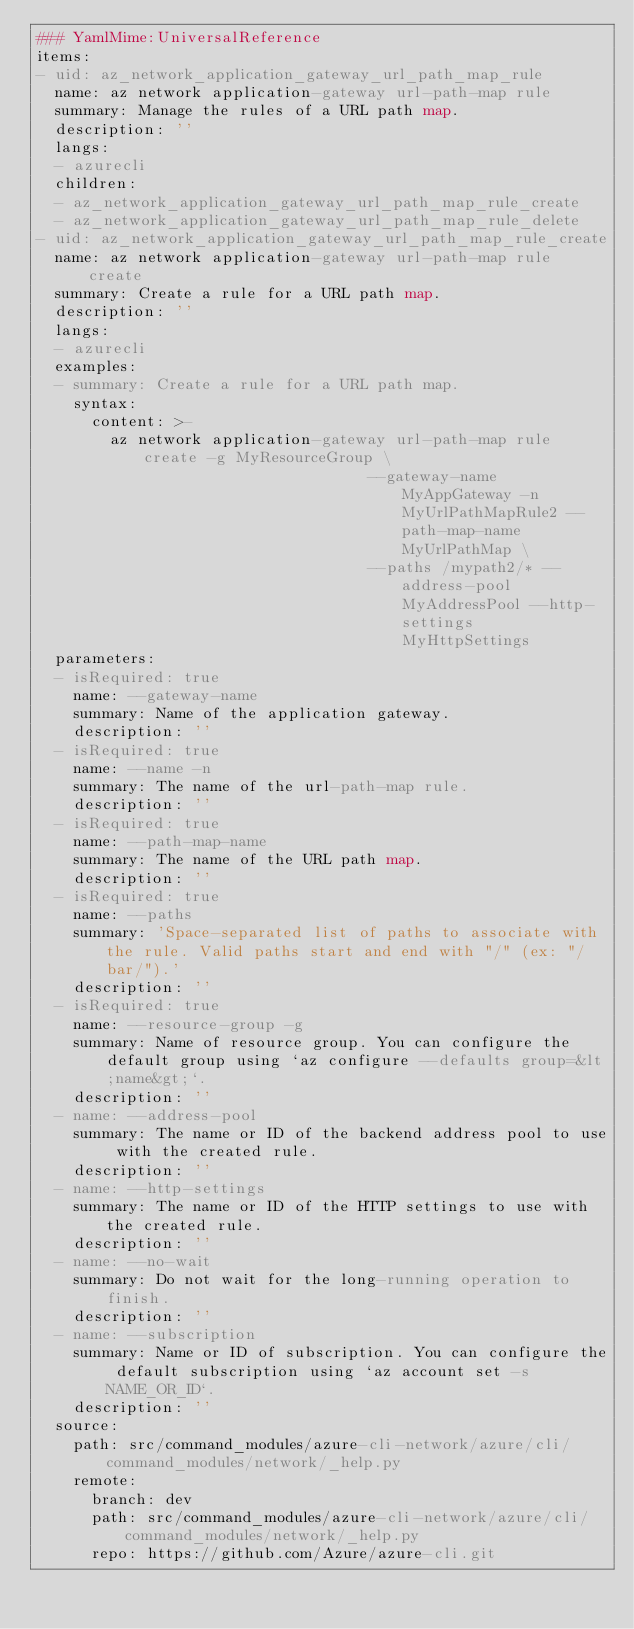<code> <loc_0><loc_0><loc_500><loc_500><_YAML_>### YamlMime:UniversalReference
items:
- uid: az_network_application_gateway_url_path_map_rule
  name: az network application-gateway url-path-map rule
  summary: Manage the rules of a URL path map.
  description: ''
  langs:
  - azurecli
  children:
  - az_network_application_gateway_url_path_map_rule_create
  - az_network_application_gateway_url_path_map_rule_delete
- uid: az_network_application_gateway_url_path_map_rule_create
  name: az network application-gateway url-path-map rule create
  summary: Create a rule for a URL path map.
  description: ''
  langs:
  - azurecli
  examples:
  - summary: Create a rule for a URL path map.
    syntax:
      content: >-
        az network application-gateway url-path-map rule create -g MyResourceGroup \
                                    --gateway-name MyAppGateway -n MyUrlPathMapRule2 --path-map-name MyUrlPathMap \
                                    --paths /mypath2/* --address-pool MyAddressPool --http-settings MyHttpSettings
  parameters:
  - isRequired: true
    name: --gateway-name
    summary: Name of the application gateway.
    description: ''
  - isRequired: true
    name: --name -n
    summary: The name of the url-path-map rule.
    description: ''
  - isRequired: true
    name: --path-map-name
    summary: The name of the URL path map.
    description: ''
  - isRequired: true
    name: --paths
    summary: 'Space-separated list of paths to associate with the rule. Valid paths start and end with "/" (ex: "/bar/").'
    description: ''
  - isRequired: true
    name: --resource-group -g
    summary: Name of resource group. You can configure the default group using `az configure --defaults group=&lt;name&gt;`.
    description: ''
  - name: --address-pool
    summary: The name or ID of the backend address pool to use with the created rule.
    description: ''
  - name: --http-settings
    summary: The name or ID of the HTTP settings to use with the created rule.
    description: ''
  - name: --no-wait
    summary: Do not wait for the long-running operation to finish.
    description: ''
  - name: --subscription
    summary: Name or ID of subscription. You can configure the default subscription using `az account set -s NAME_OR_ID`.
    description: ''
  source:
    path: src/command_modules/azure-cli-network/azure/cli/command_modules/network/_help.py
    remote:
      branch: dev
      path: src/command_modules/azure-cli-network/azure/cli/command_modules/network/_help.py
      repo: https://github.com/Azure/azure-cli.git</code> 